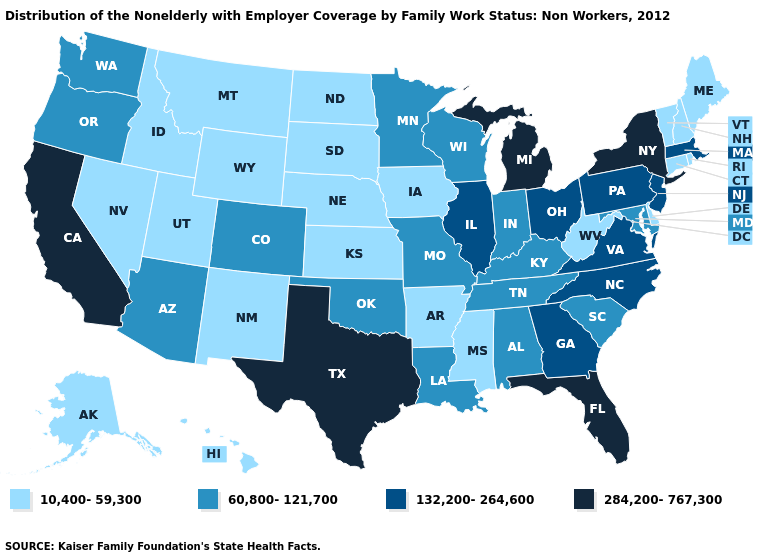Among the states that border New Hampshire , does Massachusetts have the highest value?
Answer briefly. Yes. Among the states that border Illinois , which have the lowest value?
Concise answer only. Iowa. Does the first symbol in the legend represent the smallest category?
Write a very short answer. Yes. Name the states that have a value in the range 284,200-767,300?
Short answer required. California, Florida, Michigan, New York, Texas. Does the map have missing data?
Be succinct. No. What is the lowest value in the MidWest?
Be succinct. 10,400-59,300. What is the highest value in the South ?
Quick response, please. 284,200-767,300. Among the states that border South Dakota , which have the highest value?
Write a very short answer. Minnesota. What is the lowest value in states that border Kansas?
Quick response, please. 10,400-59,300. What is the value of Montana?
Keep it brief. 10,400-59,300. What is the value of Illinois?
Concise answer only. 132,200-264,600. Name the states that have a value in the range 284,200-767,300?
Short answer required. California, Florida, Michigan, New York, Texas. Among the states that border Washington , does Idaho have the highest value?
Give a very brief answer. No. Name the states that have a value in the range 60,800-121,700?
Keep it brief. Alabama, Arizona, Colorado, Indiana, Kentucky, Louisiana, Maryland, Minnesota, Missouri, Oklahoma, Oregon, South Carolina, Tennessee, Washington, Wisconsin. Name the states that have a value in the range 132,200-264,600?
Keep it brief. Georgia, Illinois, Massachusetts, New Jersey, North Carolina, Ohio, Pennsylvania, Virginia. 